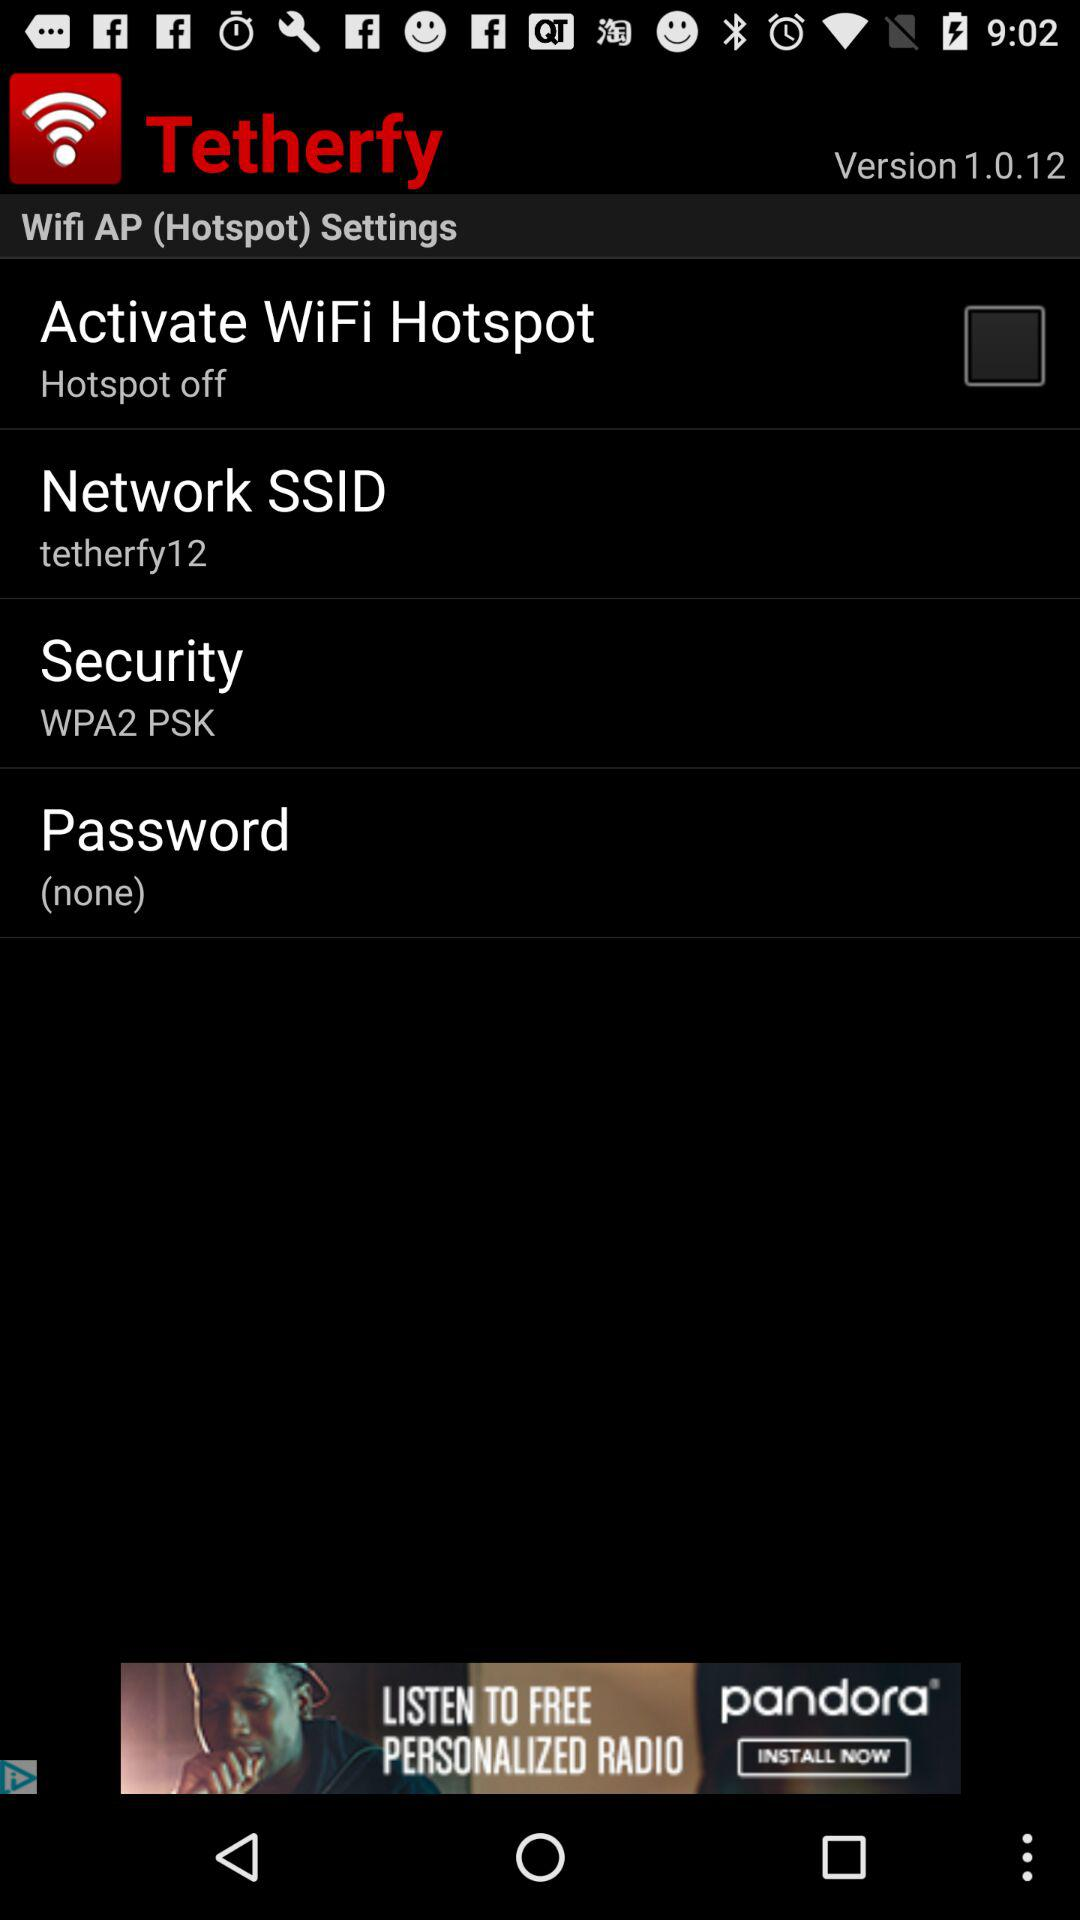What is the network SSID? The network SSID is "tetherfy12". 